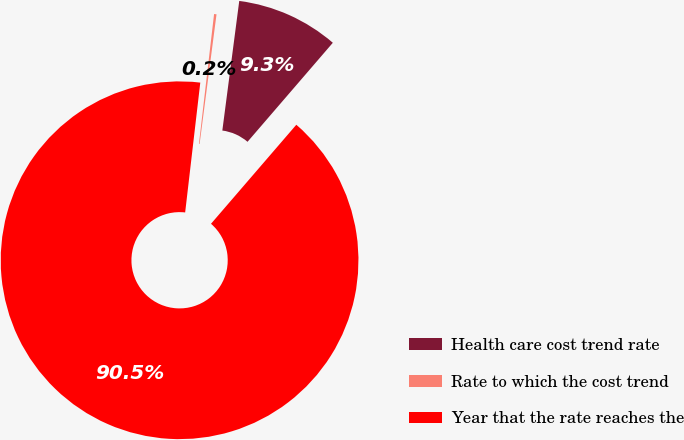<chart> <loc_0><loc_0><loc_500><loc_500><pie_chart><fcel>Health care cost trend rate<fcel>Rate to which the cost trend<fcel>Year that the rate reaches the<nl><fcel>9.25%<fcel>0.22%<fcel>90.52%<nl></chart> 